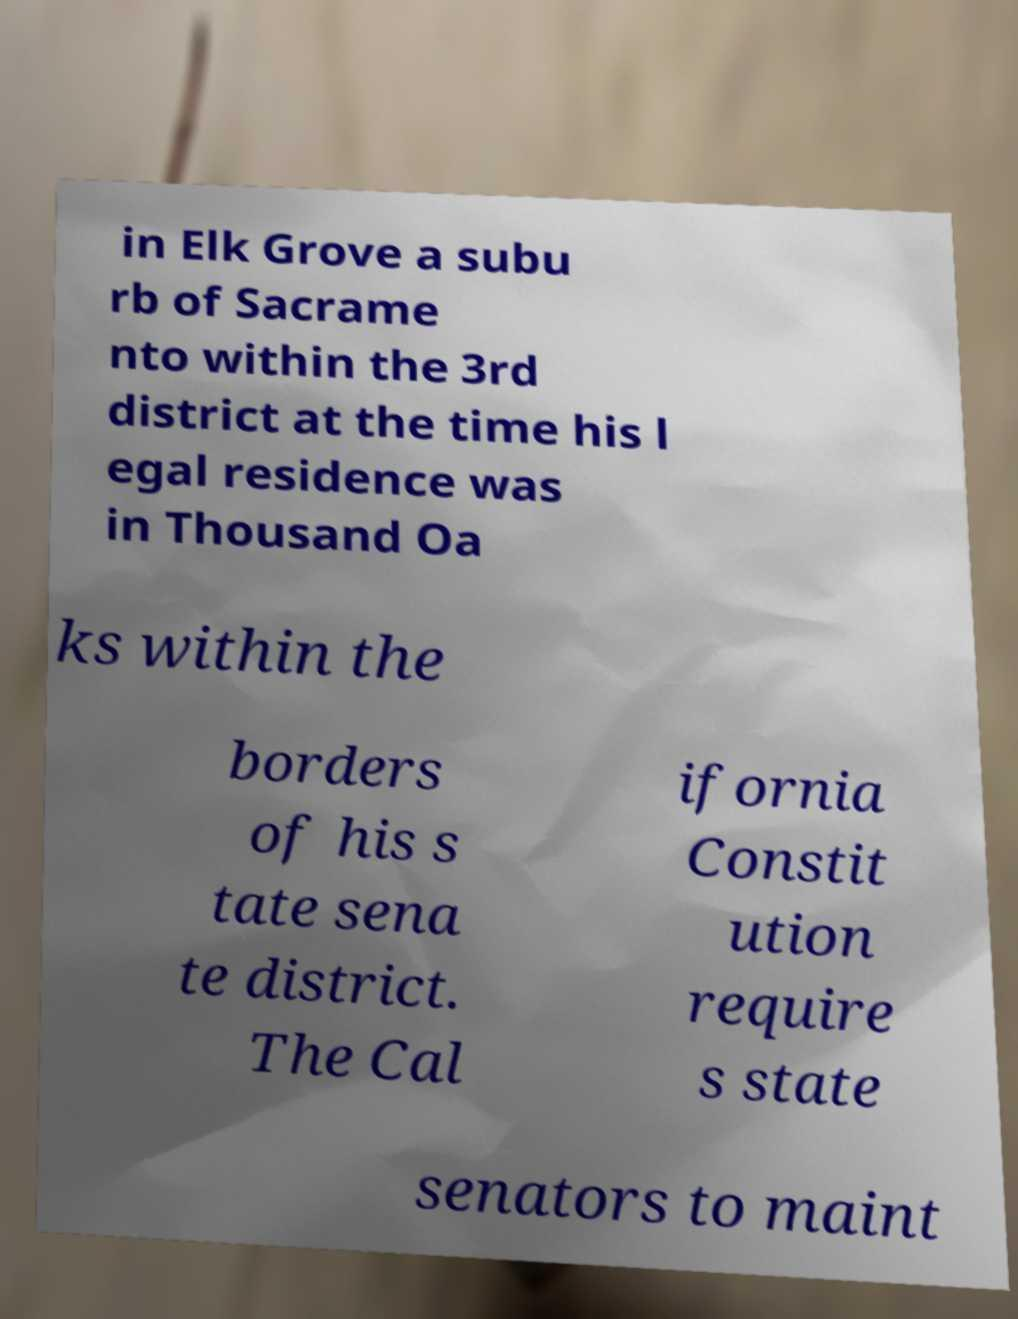I need the written content from this picture converted into text. Can you do that? in Elk Grove a subu rb of Sacrame nto within the 3rd district at the time his l egal residence was in Thousand Oa ks within the borders of his s tate sena te district. The Cal ifornia Constit ution require s state senators to maint 